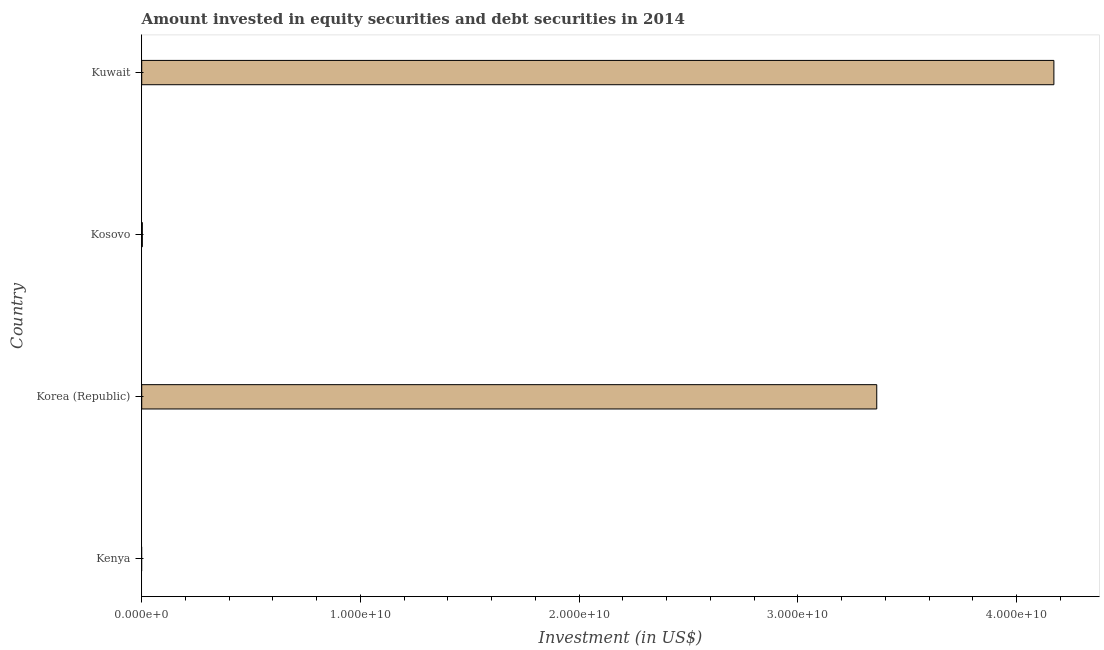Does the graph contain any zero values?
Your answer should be compact. Yes. What is the title of the graph?
Your answer should be compact. Amount invested in equity securities and debt securities in 2014. What is the label or title of the X-axis?
Provide a succinct answer. Investment (in US$). What is the portfolio investment in Kuwait?
Provide a short and direct response. 4.17e+1. Across all countries, what is the maximum portfolio investment?
Make the answer very short. 4.17e+1. In which country was the portfolio investment maximum?
Provide a succinct answer. Kuwait. What is the sum of the portfolio investment?
Ensure brevity in your answer.  7.53e+1. What is the difference between the portfolio investment in Korea (Republic) and Kosovo?
Keep it short and to the point. 3.36e+1. What is the average portfolio investment per country?
Ensure brevity in your answer.  1.88e+1. What is the median portfolio investment?
Your response must be concise. 1.68e+1. Is the difference between the portfolio investment in Korea (Republic) and Kosovo greater than the difference between any two countries?
Provide a succinct answer. No. What is the difference between the highest and the second highest portfolio investment?
Your response must be concise. 8.10e+09. What is the difference between the highest and the lowest portfolio investment?
Provide a succinct answer. 4.17e+1. What is the difference between two consecutive major ticks on the X-axis?
Your answer should be very brief. 1.00e+1. What is the Investment (in US$) in Kenya?
Provide a short and direct response. 0. What is the Investment (in US$) of Korea (Republic)?
Offer a very short reply. 3.36e+1. What is the Investment (in US$) in Kosovo?
Offer a terse response. 2.76e+07. What is the Investment (in US$) of Kuwait?
Give a very brief answer. 4.17e+1. What is the difference between the Investment (in US$) in Korea (Republic) and Kosovo?
Offer a terse response. 3.36e+1. What is the difference between the Investment (in US$) in Korea (Republic) and Kuwait?
Provide a short and direct response. -8.10e+09. What is the difference between the Investment (in US$) in Kosovo and Kuwait?
Your response must be concise. -4.17e+1. What is the ratio of the Investment (in US$) in Korea (Republic) to that in Kosovo?
Give a very brief answer. 1218.61. What is the ratio of the Investment (in US$) in Korea (Republic) to that in Kuwait?
Give a very brief answer. 0.81. 